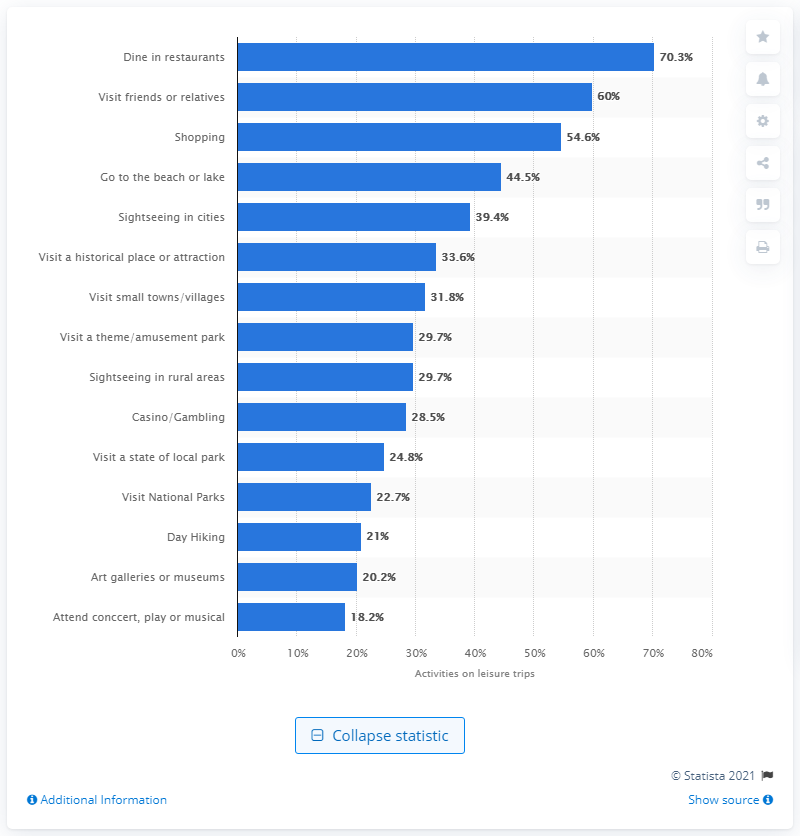What can you tell me about the least popular activity shown? The least popular activity among those listed is attending concerts, plays, or musicals, with only 18.2% of travellers engaging in this activity during leisure trips. 